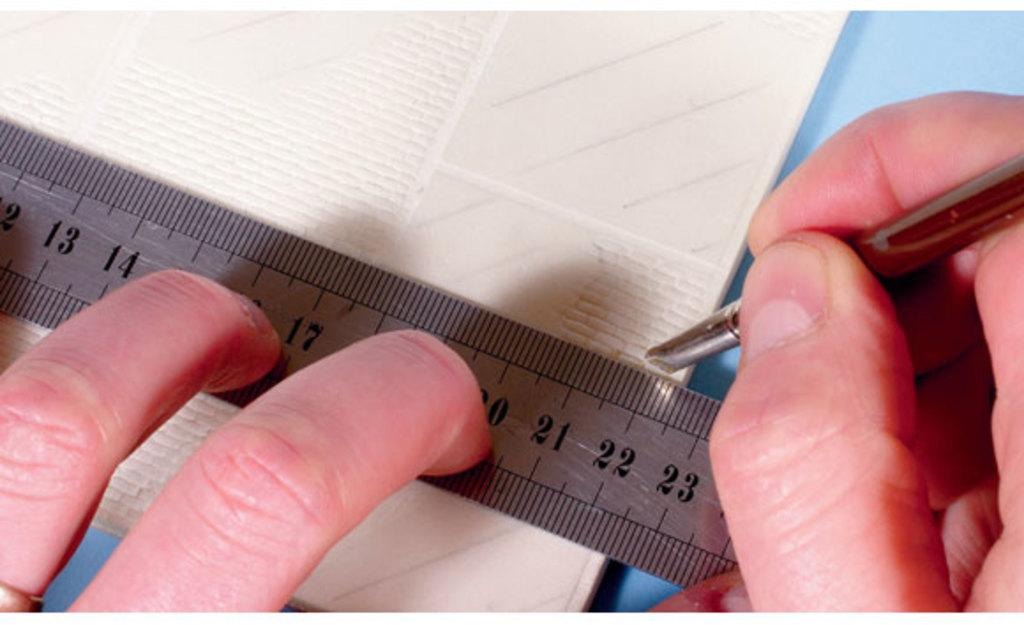<image>
Render a clear and concise summary of the photo. A person using a metal ruler to mark 22" on the back of a tile. 